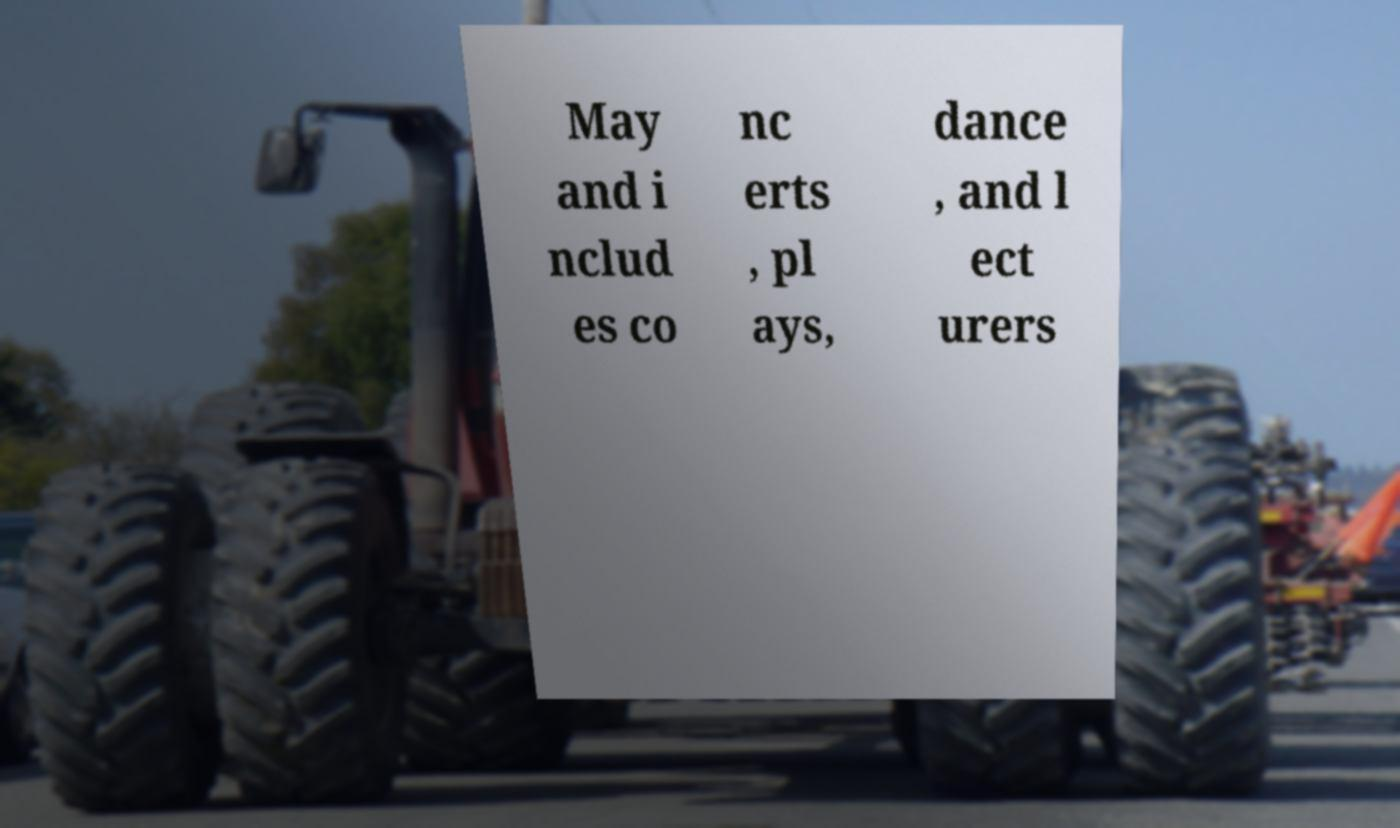Can you read and provide the text displayed in the image?This photo seems to have some interesting text. Can you extract and type it out for me? May and i nclud es co nc erts , pl ays, dance , and l ect urers 